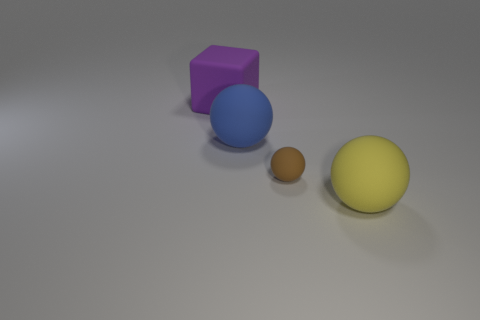Add 4 brown matte spheres. How many objects exist? 8 Subtract all yellow spheres. How many spheres are left? 2 Subtract all yellow balls. How many balls are left? 2 Subtract all balls. Subtract all purple matte cubes. How many objects are left? 0 Add 3 big purple cubes. How many big purple cubes are left? 4 Add 3 small yellow cylinders. How many small yellow cylinders exist? 3 Subtract 0 blue cylinders. How many objects are left? 4 Subtract all spheres. How many objects are left? 1 Subtract all green spheres. Subtract all green cylinders. How many spheres are left? 3 